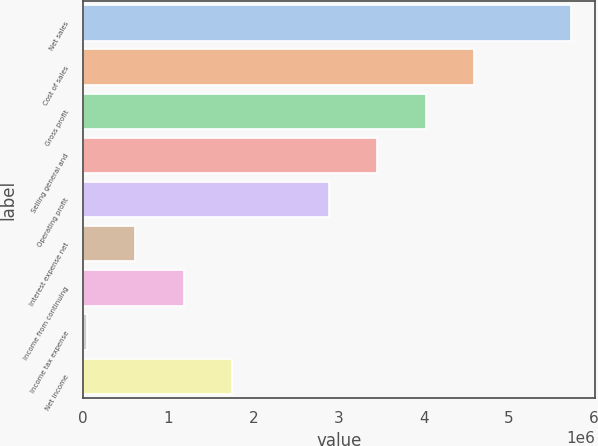Convert chart. <chart><loc_0><loc_0><loc_500><loc_500><bar_chart><fcel>Net sales<fcel>Cost of sales<fcel>Gross profit<fcel>Selling general and<fcel>Operating profit<fcel>Interest expense net<fcel>Income from continuing<fcel>Income tax expense<fcel>Net income<nl><fcel>5.73155e+06<fcel>4.59424e+06<fcel>4.02559e+06<fcel>3.45694e+06<fcel>2.88828e+06<fcel>613671<fcel>1.18232e+06<fcel>45018<fcel>1.75098e+06<nl></chart> 